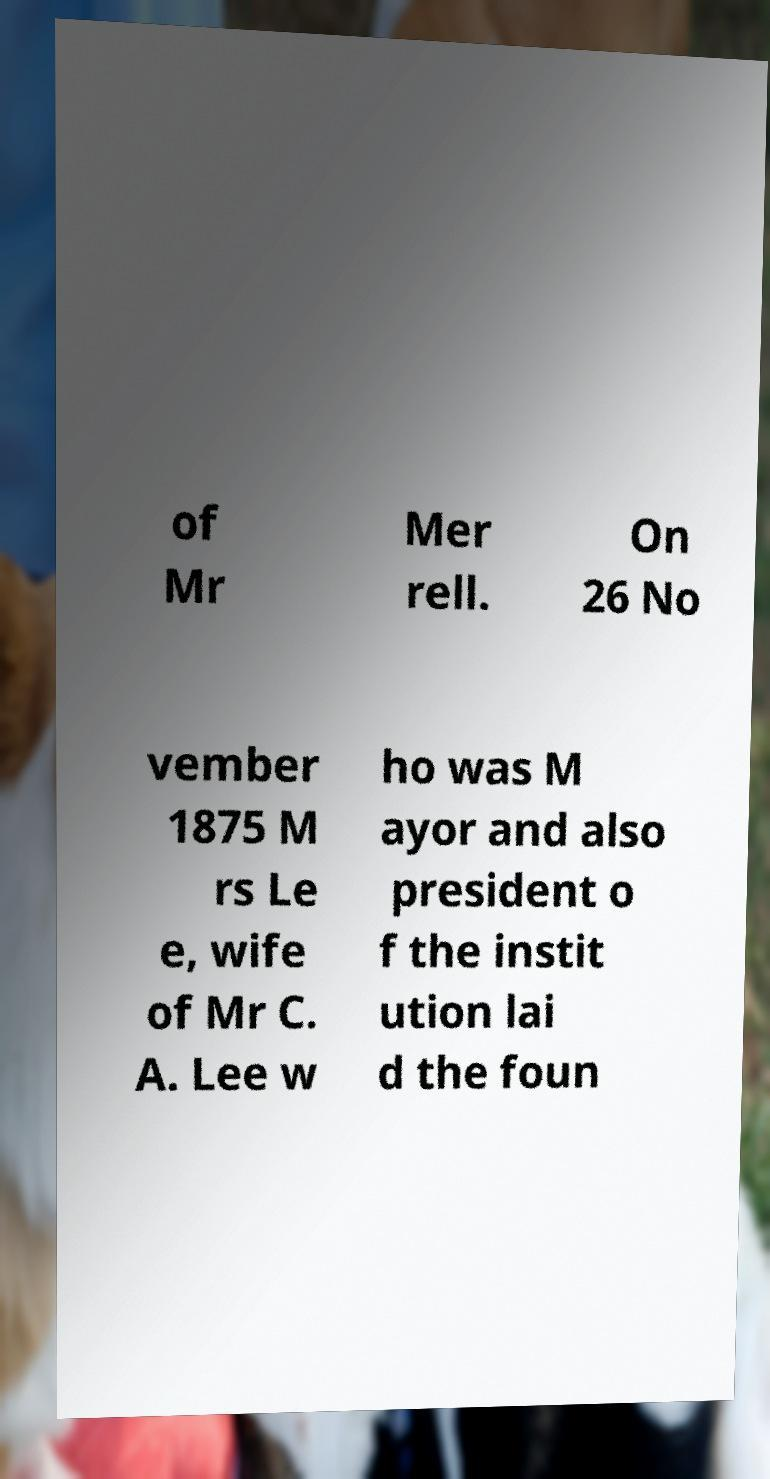Could you assist in decoding the text presented in this image and type it out clearly? of Mr Mer rell. On 26 No vember 1875 M rs Le e, wife of Mr C. A. Lee w ho was M ayor and also president o f the instit ution lai d the foun 